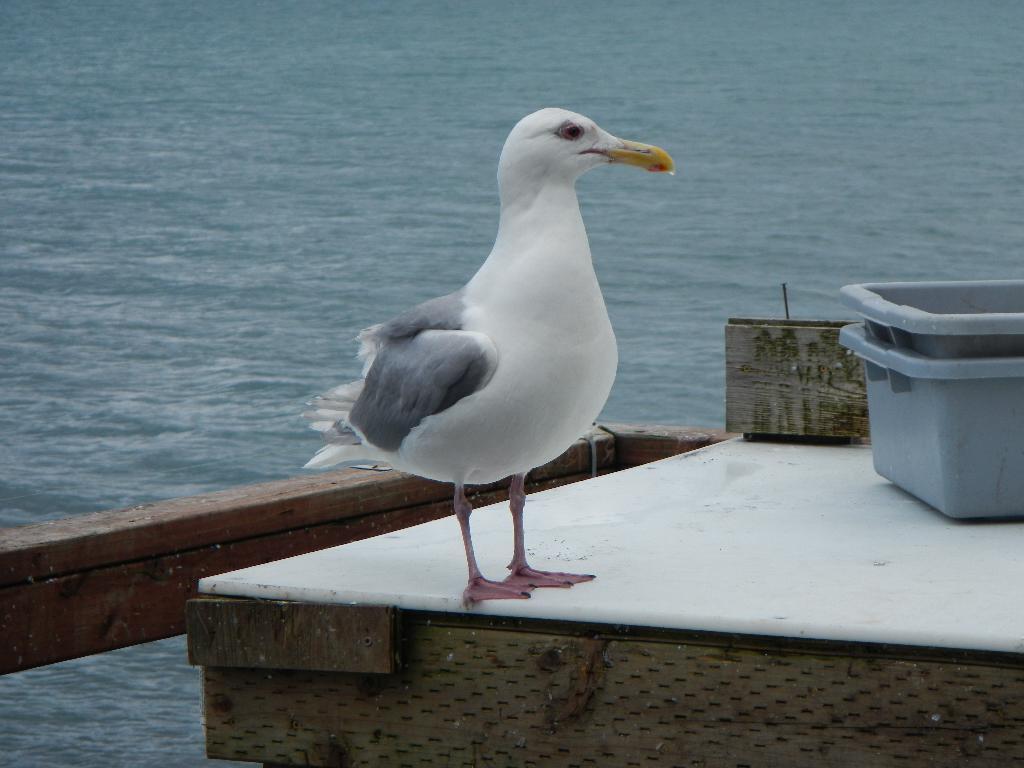Can you describe this image briefly? In this picture I can see there is a bird here and it is having a long yellow beak and there is a grey color box, placed on to right and there is a ocean in the backdrop. 